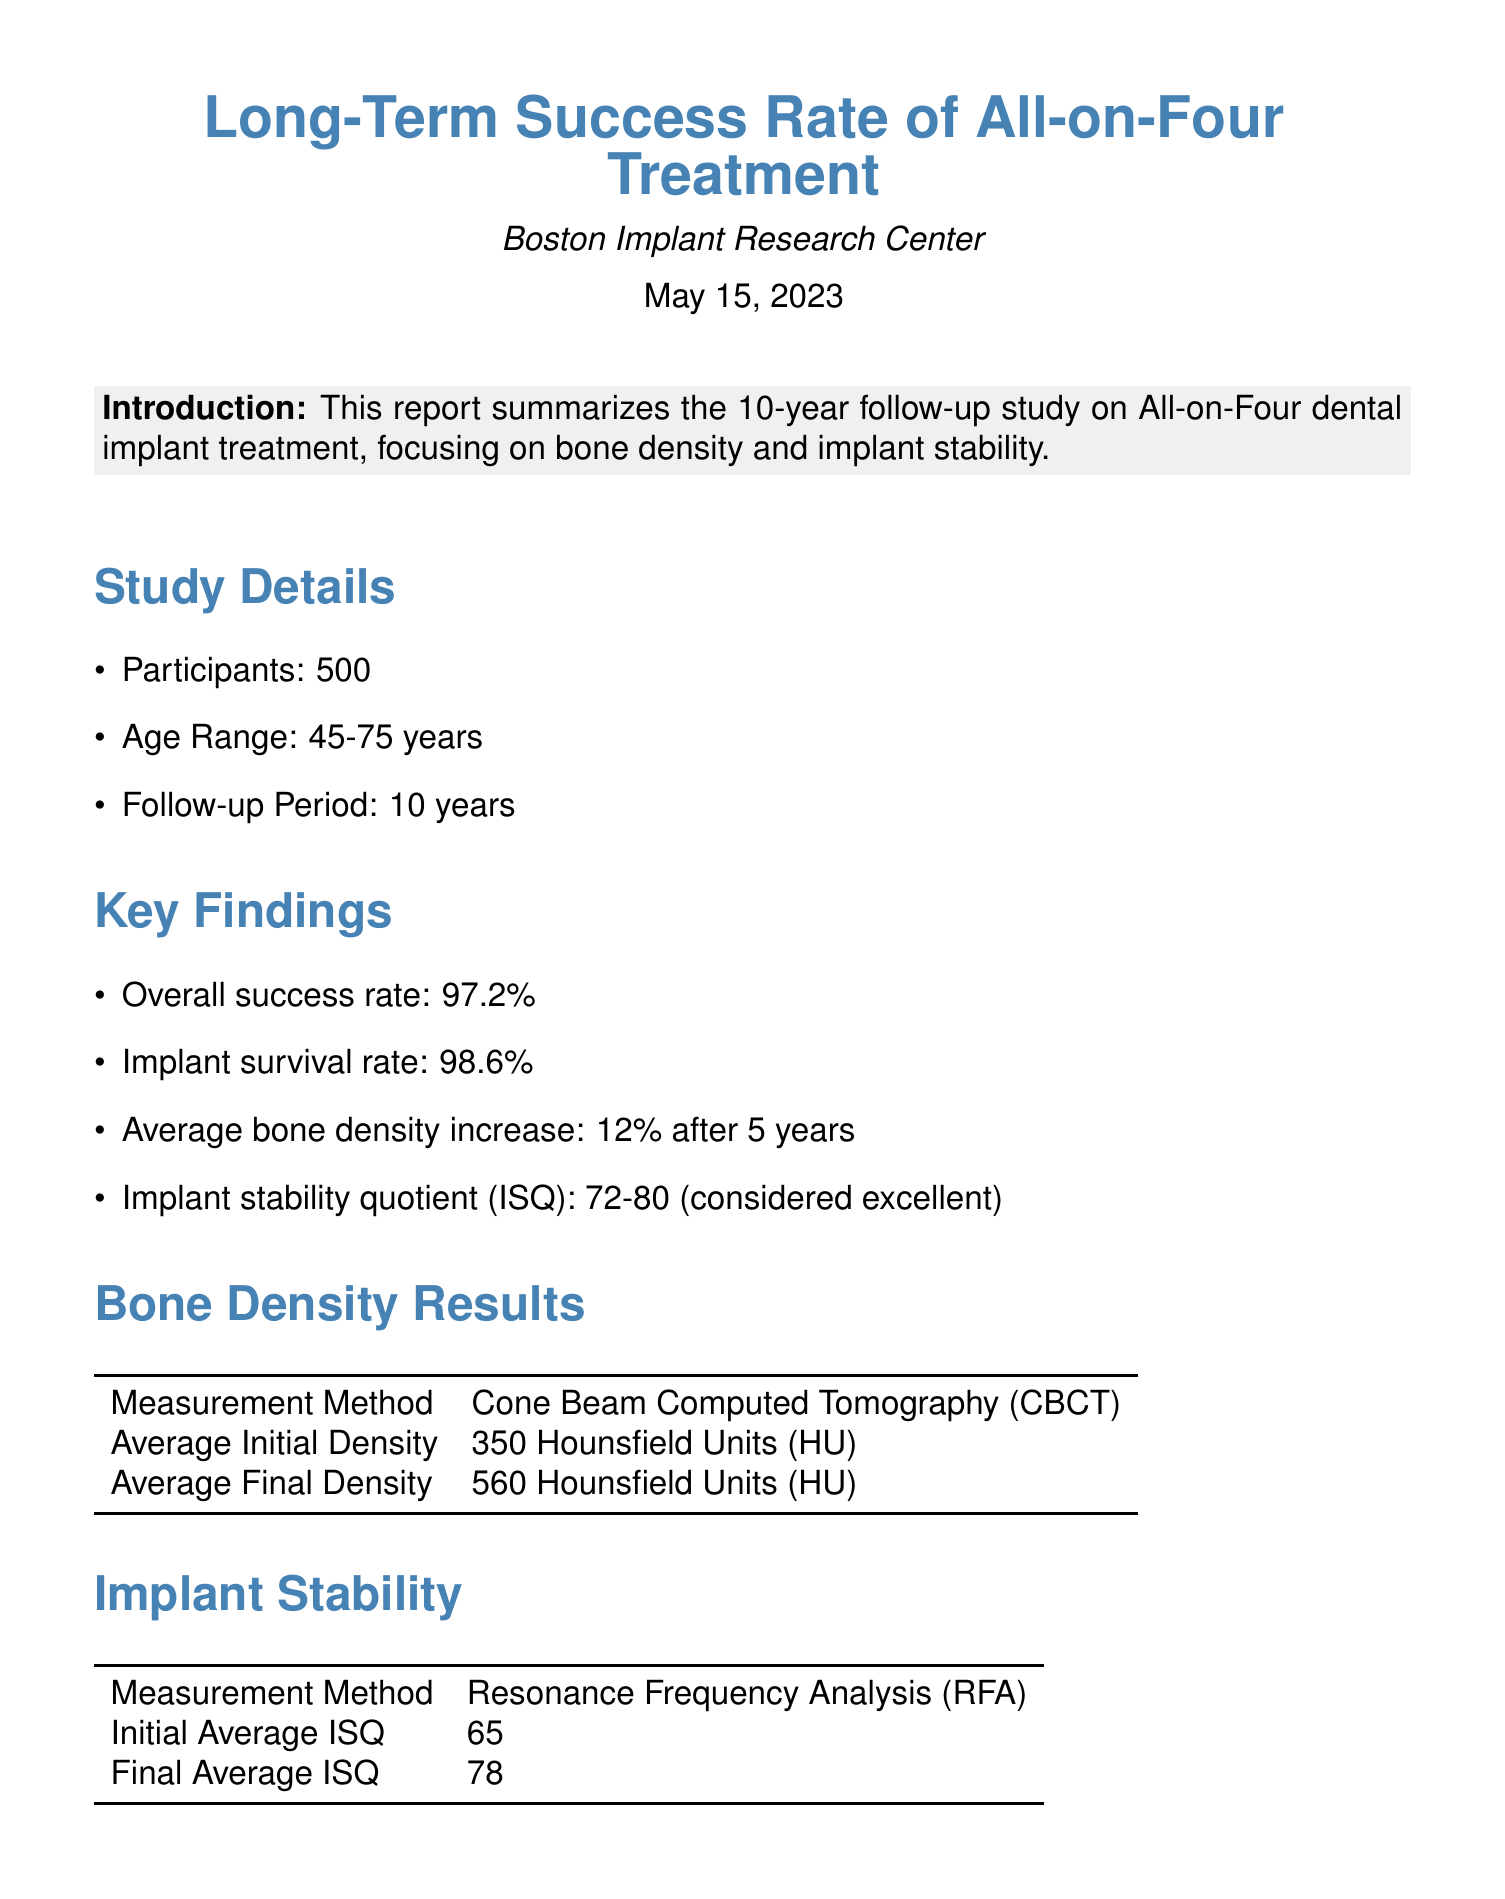what is the overall success rate? The overall success rate is stated in the findings section of the report.
Answer: 97.2% what is the initial average ISQ? The initial average ISQ is provided in the implant stability section of the report.
Answer: 65 how many participants were in the study? The number of participants is mentioned in the study details section.
Answer: 500 what was the age range of participants? The age range of participants is included in the study details section.
Answer: 45-75 years what is the average bone density increase after 5 years? The average bone density increase is specified in the key findings.
Answer: 12% what method was used to measure bone density? The method for measuring bone density is indicated in the bone density results section.
Answer: Cone Beam Computed Tomography (CBCT) what is the final average ISQ? The final average ISQ is provided in the implant stability section of the report.
Answer: 78 who is the researcher? The researcher’s name is given at the end of the document.
Answer: Dr. Emily Winters, DDS, PhD what is the follow-up period of the study? The follow-up period is detailed in the study details section.
Answer: 10 years what is the contact email for the researcher? The contact email for the researcher is provided at the end of the document.
Answer: ewinters@bostonimplantresearch.org 